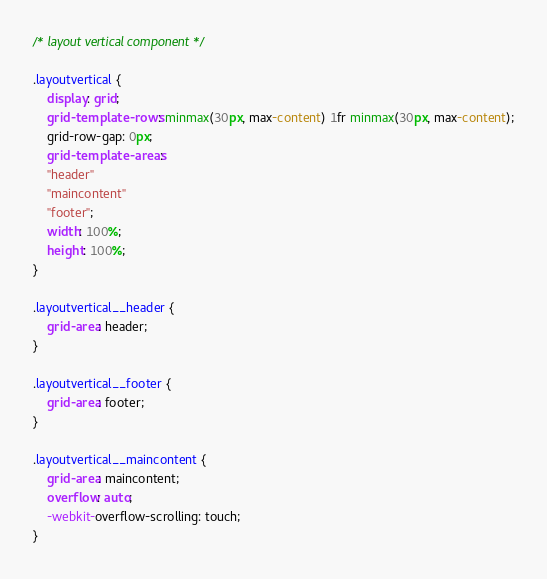<code> <loc_0><loc_0><loc_500><loc_500><_CSS_>/* layout vertical component */

.layoutvertical {
    display: grid;
    grid-template-rows: minmax(30px, max-content) 1fr minmax(30px, max-content);
    grid-row-gap: 0px;
    grid-template-areas: 
    "header"
    "maincontent"
    "footer";
    width: 100%;
    height: 100%;
}

.layoutvertical__header {
    grid-area: header;
}

.layoutvertical__footer {
    grid-area: footer;
}

.layoutvertical__maincontent {
    grid-area: maincontent;
    overflow: auto;
    -webkit-overflow-scrolling: touch;
}</code> 